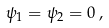Convert formula to latex. <formula><loc_0><loc_0><loc_500><loc_500>\psi _ { 1 } = \psi _ { 2 } = 0 \, ,</formula> 